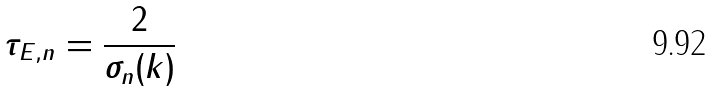Convert formula to latex. <formula><loc_0><loc_0><loc_500><loc_500>\tau _ { E , n } = \frac { 2 } { \sigma _ { n } ( k ) }</formula> 